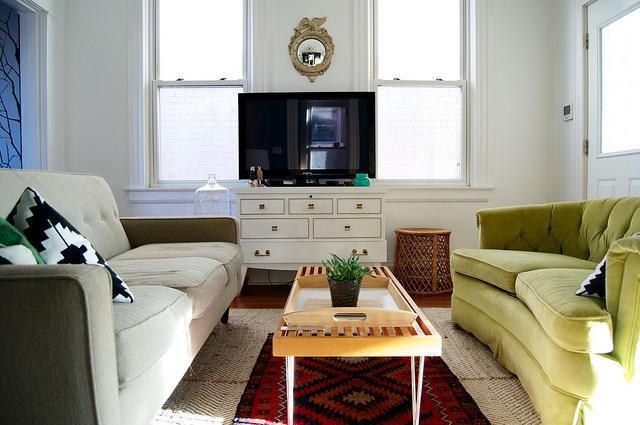How many couches are in the picture?
Give a very brief answer. 2. 